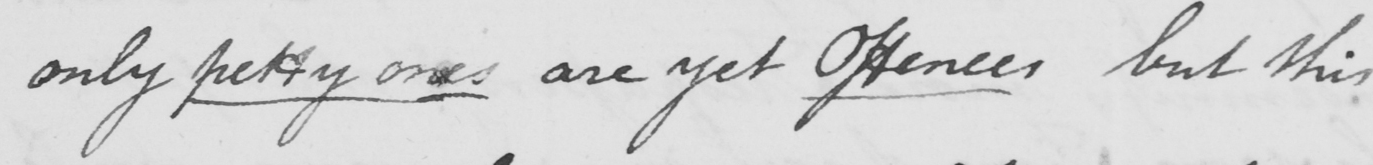Please transcribe the handwritten text in this image. only petty ones are yet Offences but this 